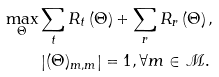Convert formula to latex. <formula><loc_0><loc_0><loc_500><loc_500>\max _ { \Theta } & \sum _ { t } R _ { t } \left ( \Theta \right ) + \sum _ { r } R _ { r } \left ( \Theta \right ) , \\ & \left | ( \Theta ) _ { m , m } \right | = 1 , \forall m \in \mathcal { M } .</formula> 